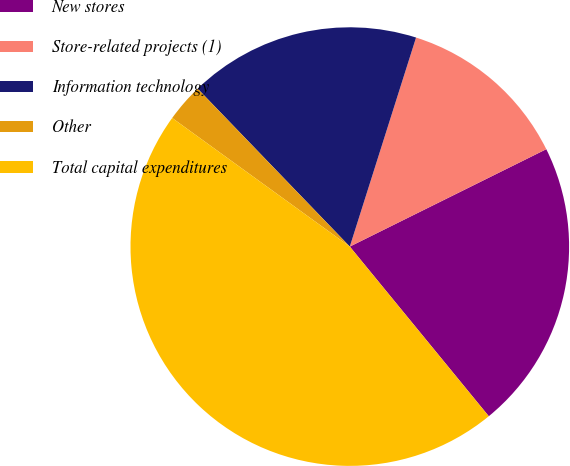<chart> <loc_0><loc_0><loc_500><loc_500><pie_chart><fcel>New stores<fcel>Store-related projects (1)<fcel>Information technology<fcel>Other<fcel>Total capital expenditures<nl><fcel>21.4%<fcel>12.79%<fcel>17.09%<fcel>2.82%<fcel>45.9%<nl></chart> 